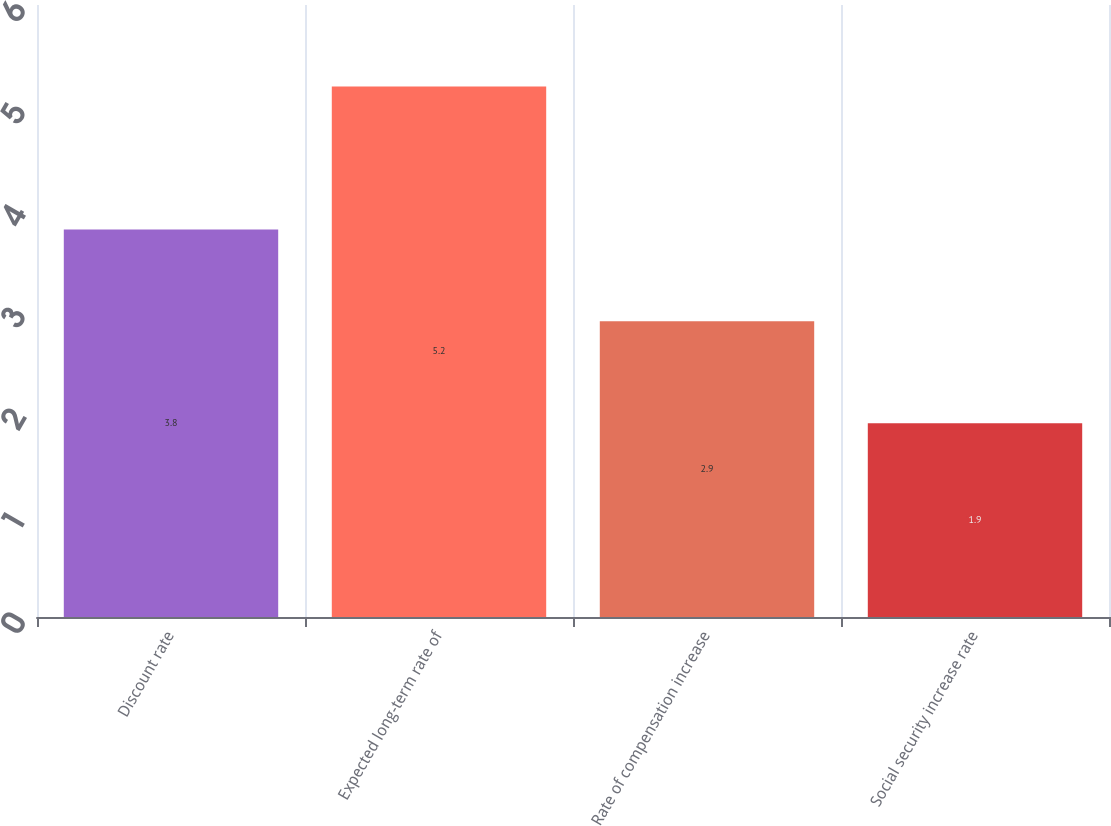Convert chart to OTSL. <chart><loc_0><loc_0><loc_500><loc_500><bar_chart><fcel>Discount rate<fcel>Expected long-term rate of<fcel>Rate of compensation increase<fcel>Social security increase rate<nl><fcel>3.8<fcel>5.2<fcel>2.9<fcel>1.9<nl></chart> 